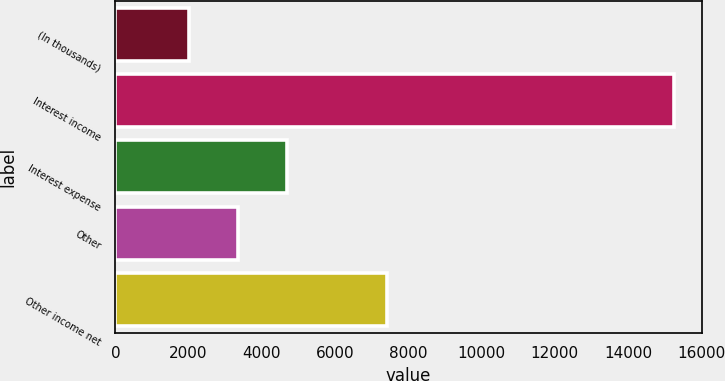<chart> <loc_0><loc_0><loc_500><loc_500><bar_chart><fcel>(In thousands)<fcel>Interest income<fcel>Interest expense<fcel>Other<fcel>Other income net<nl><fcel>2016<fcel>15252<fcel>4675.6<fcel>3352<fcel>7421<nl></chart> 